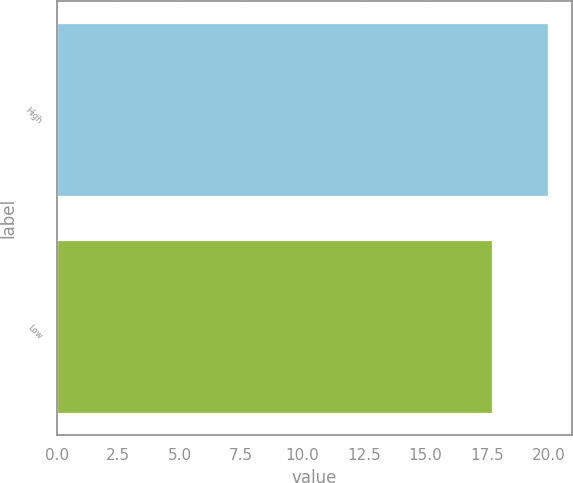Convert chart to OTSL. <chart><loc_0><loc_0><loc_500><loc_500><bar_chart><fcel>High<fcel>Low<nl><fcel>19.97<fcel>17.7<nl></chart> 